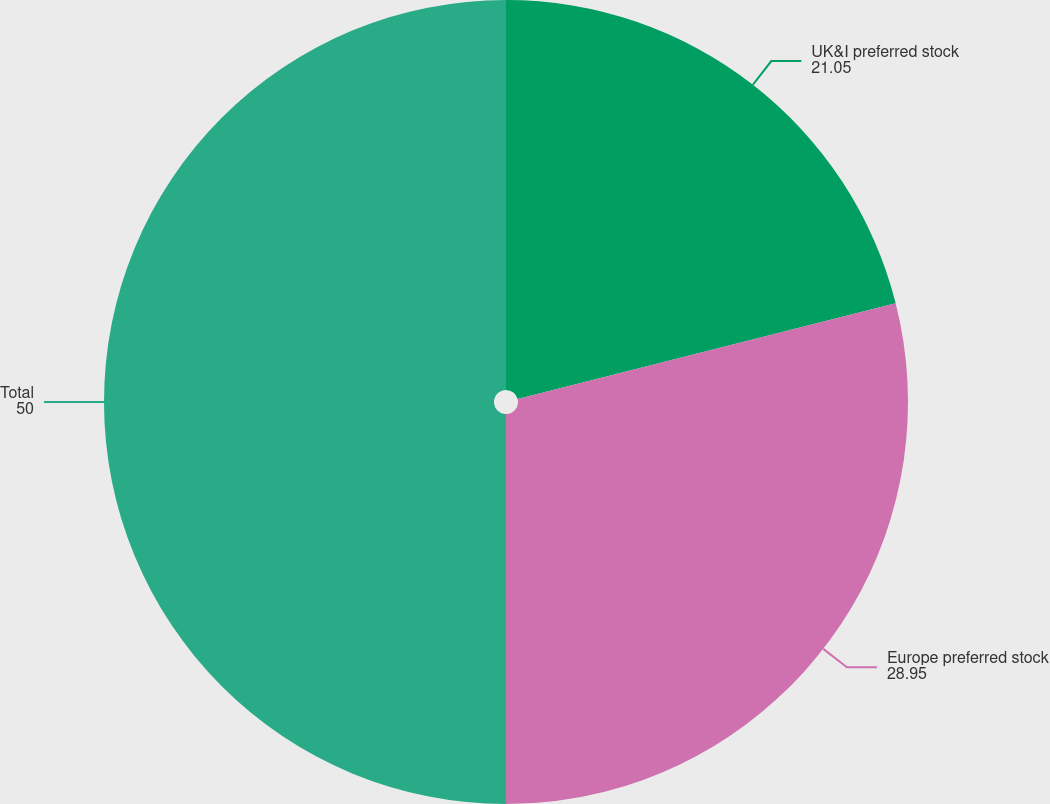<chart> <loc_0><loc_0><loc_500><loc_500><pie_chart><fcel>UK&I preferred stock<fcel>Europe preferred stock<fcel>Total<nl><fcel>21.05%<fcel>28.95%<fcel>50.0%<nl></chart> 